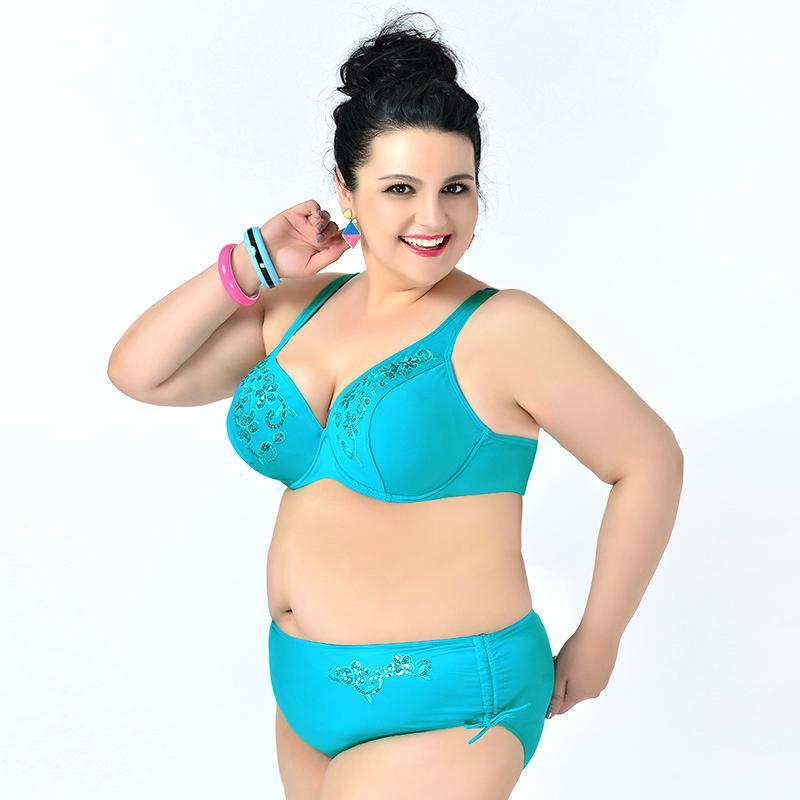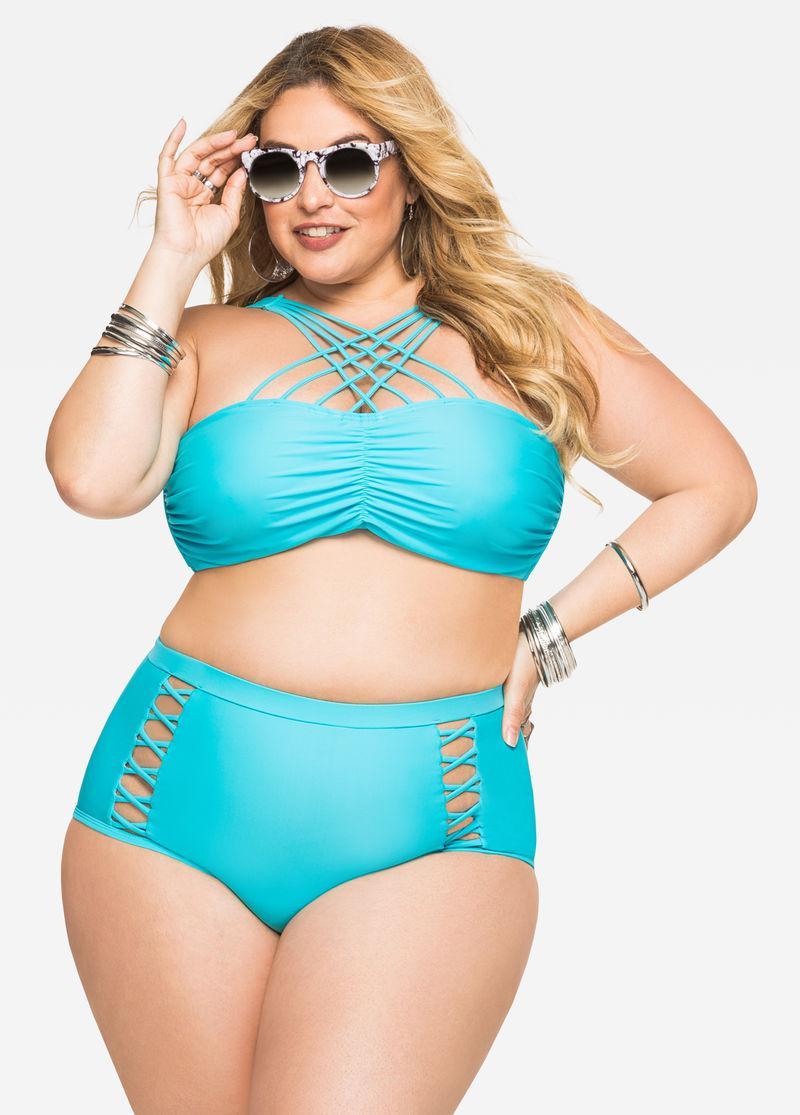The first image is the image on the left, the second image is the image on the right. Analyze the images presented: Is the assertion "At least one image features a model in matching-colored solid aqua bikini." valid? Answer yes or no. Yes. The first image is the image on the left, the second image is the image on the right. Examine the images to the left and right. Is the description "There are two bikinis that are primarily blue in color" accurate? Answer yes or no. Yes. 